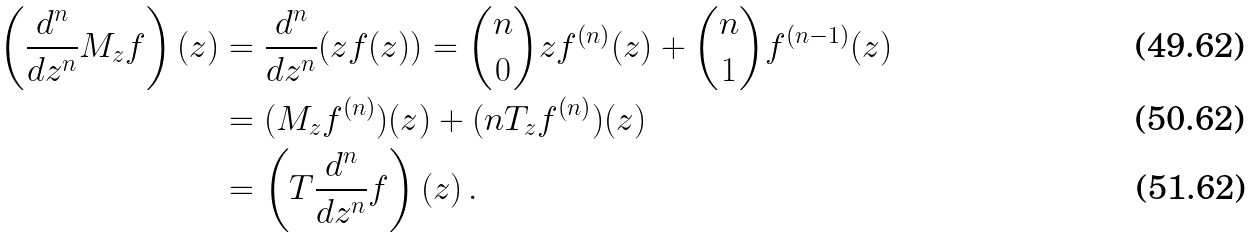<formula> <loc_0><loc_0><loc_500><loc_500>\left ( \frac { d ^ { n } } { d z ^ { n } } M _ { z } f \right ) ( z ) & = \frac { d ^ { n } } { d z ^ { n } } ( z f ( z ) ) = \binom { n } { 0 } z f ^ { ( n ) } ( z ) + \binom { n } { 1 } f ^ { ( n - 1 ) } ( z ) \\ & = ( M _ { z } f ^ { ( n ) } ) ( z ) + ( n T _ { z } f ^ { ( n ) } ) ( z ) \\ & = \left ( T \frac { d ^ { n } } { d z ^ { n } } f \right ) ( z ) \, .</formula> 